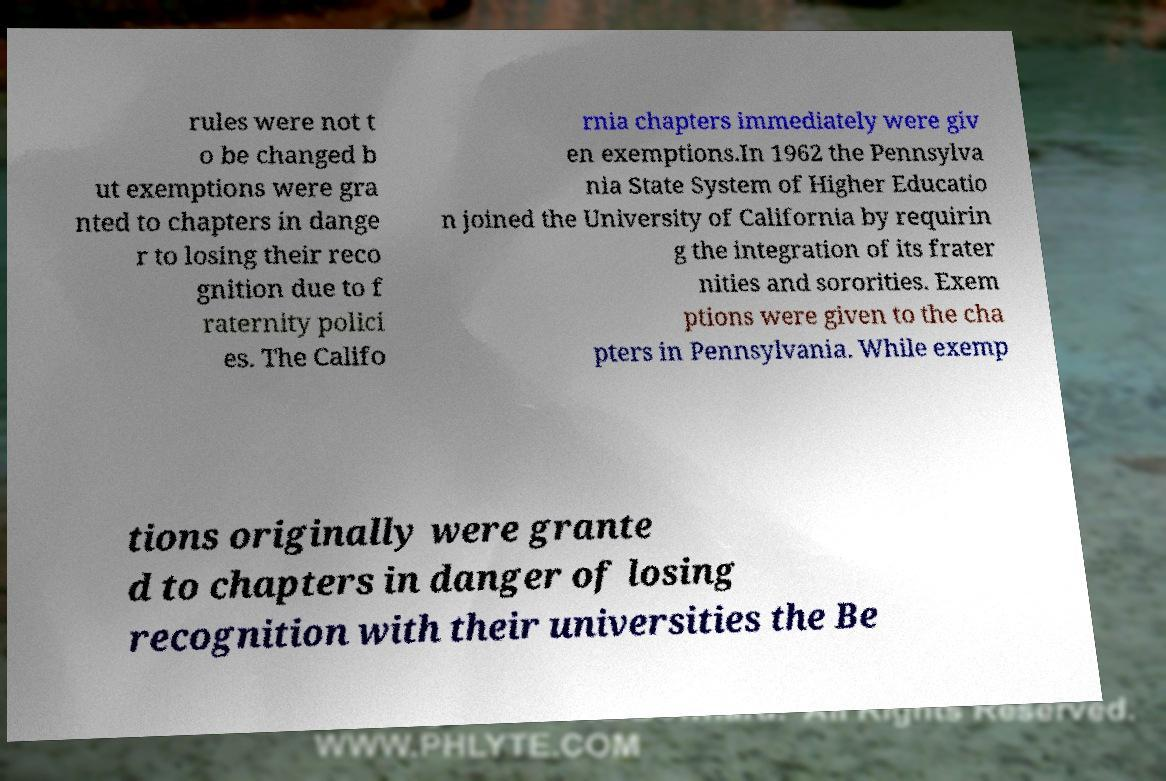What messages or text are displayed in this image? I need them in a readable, typed format. rules were not t o be changed b ut exemptions were gra nted to chapters in dange r to losing their reco gnition due to f raternity polici es. The Califo rnia chapters immediately were giv en exemptions.In 1962 the Pennsylva nia State System of Higher Educatio n joined the University of California by requirin g the integration of its frater nities and sororities. Exem ptions were given to the cha pters in Pennsylvania. While exemp tions originally were grante d to chapters in danger of losing recognition with their universities the Be 